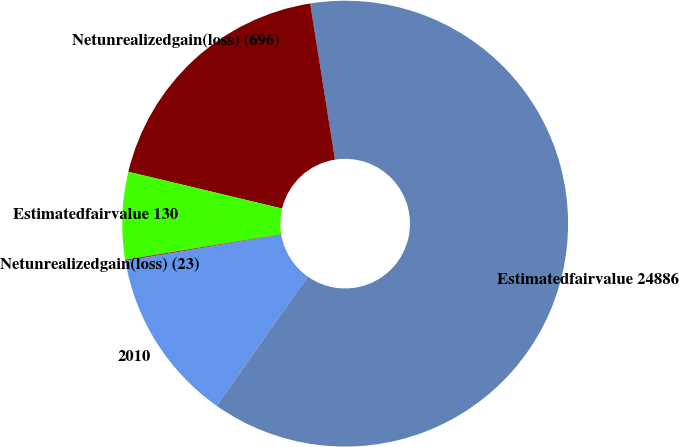Convert chart to OTSL. <chart><loc_0><loc_0><loc_500><loc_500><pie_chart><fcel>2010<fcel>Estimatedfairvalue 24886<fcel>Netunrealizedgain(loss) (696)<fcel>Estimatedfairvalue 130<fcel>Netunrealizedgain(loss) (23)<nl><fcel>12.54%<fcel>62.3%<fcel>18.76%<fcel>6.32%<fcel>0.1%<nl></chart> 